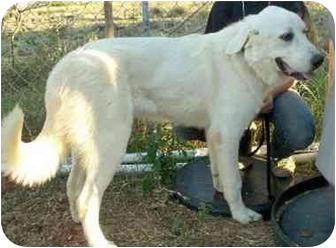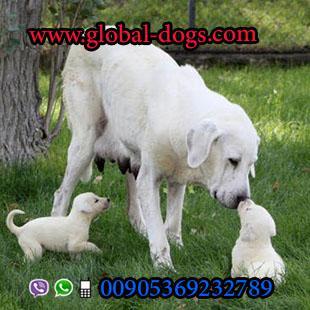The first image is the image on the left, the second image is the image on the right. Assess this claim about the two images: "The right image contains exactly one white dog.". Correct or not? Answer yes or no. No. The first image is the image on the left, the second image is the image on the right. Evaluate the accuracy of this statement regarding the images: "An image includes a large white dog on the grass next to a sitting puppy with its nose raised to the adult dog's face.". Is it true? Answer yes or no. Yes. 